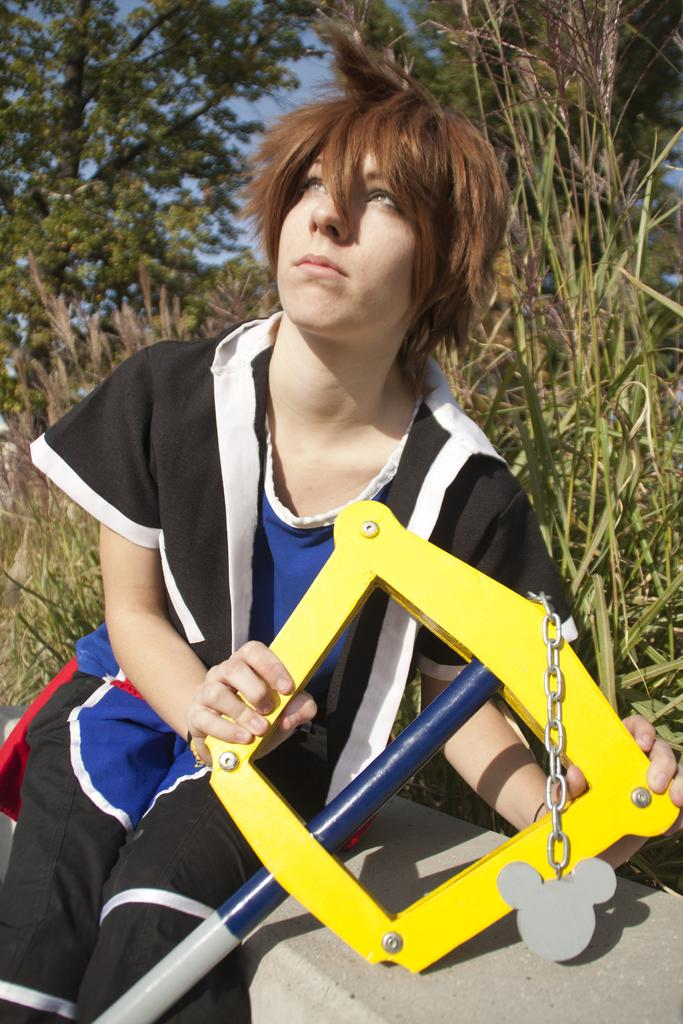What is the person in the image doing? The person is sitting on a wall in the image. What is the person holding in the image? The person is holding an object in the image. What can be seen in the background of the image? There are trees and the sky visible in the background of the image. What type of pain is the person experiencing in the image? There is no indication in the image that the person is experiencing any pain. 